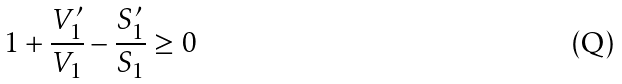<formula> <loc_0><loc_0><loc_500><loc_500>1 + \frac { V ^ { \prime } _ { 1 } } { V _ { 1 } } - \frac { S ^ { \prime } _ { 1 } } { S _ { 1 } } \geq 0</formula> 